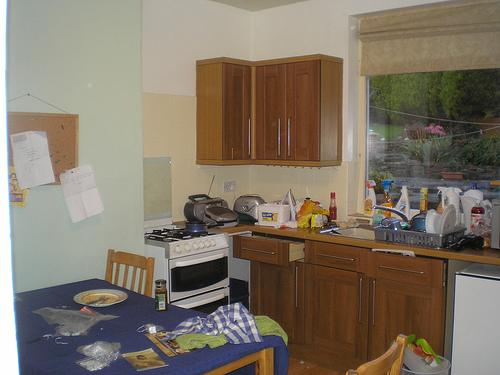What kind of furniture is present and its condition in the kitchen? The kitchen has wooden cabinets with long pulls, a compact stove and dishwasher, and a messy dining table with dish cloths and dirty dishes on it. Describe the various items placed on the table in the kitchen. There are dish cloths, dirty dishes, and a plate with 2 utensils on the messy dining table in the kitchen. Mention some characteristics of the kitchen cabinets and their location in the image. Wooden kitchen cabinets are located in the corner, with a variety of sizes and heights, and feature long pulls on the doors. List some items found on the walls and near the window of the kitchen in the image. Schedule on corkboard with colored pins, brown cabinet hanging on the wall, window plants, and cleaning supplies on the windowsill. Describe the window and its surroundings in the image. The window has a rolling shade and is surrounded by cleaning supplies on the windowsill, with plants and flowers outside, and stone steps nearby. Briefly describe what someone might see when looking at the image of the kitchen overall. A disorganized kitchen with numerous cupboards, dirty dishes, and various items scattered throughout the countertops and dining table. Describe the condition of the kitchen and some items on the countertop. The kitchen is messy and in need of cleaning, with a hot sauce, unused push pins, a radio, and a plate with 2 utensils on the countertop. In a concise manner, mention the overall condition and some items present in the kitchen. It's a cluttered kitchen with wooden cupboards, a messy countertop, dirty dishes, window plants, and a radio antenna. Mention the items found near the stove in the image. Near the stove, there is a blue silver black pot on a gas range, an oven with a small frying pan on top, and a press type electric cooking grill. Provide a brief overview of the image, highlighting the main elements in the scene. A cluttered kitchen with dirty dishes, wooden cabinets, a stove with 2 ovens, a window with flowers, and various kitchen supplies scattered on the countertops. 